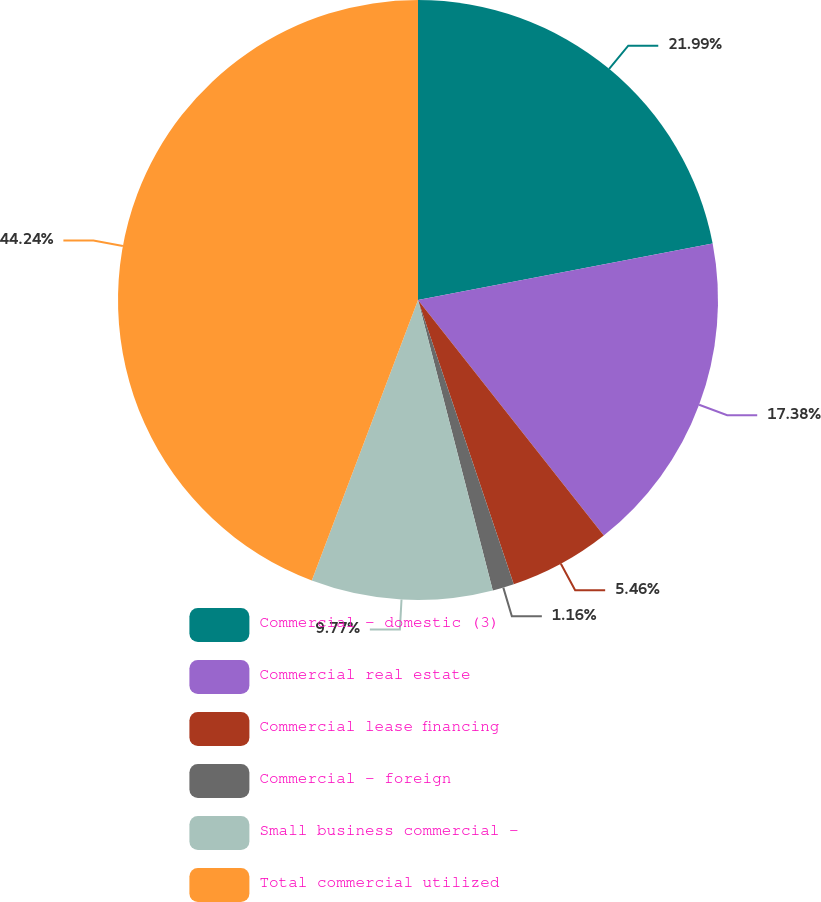Convert chart to OTSL. <chart><loc_0><loc_0><loc_500><loc_500><pie_chart><fcel>Commercial - domestic (3)<fcel>Commercial real estate<fcel>Commercial lease financing<fcel>Commercial - foreign<fcel>Small business commercial -<fcel>Total commercial utilized<nl><fcel>21.99%<fcel>17.38%<fcel>5.46%<fcel>1.16%<fcel>9.77%<fcel>44.24%<nl></chart> 